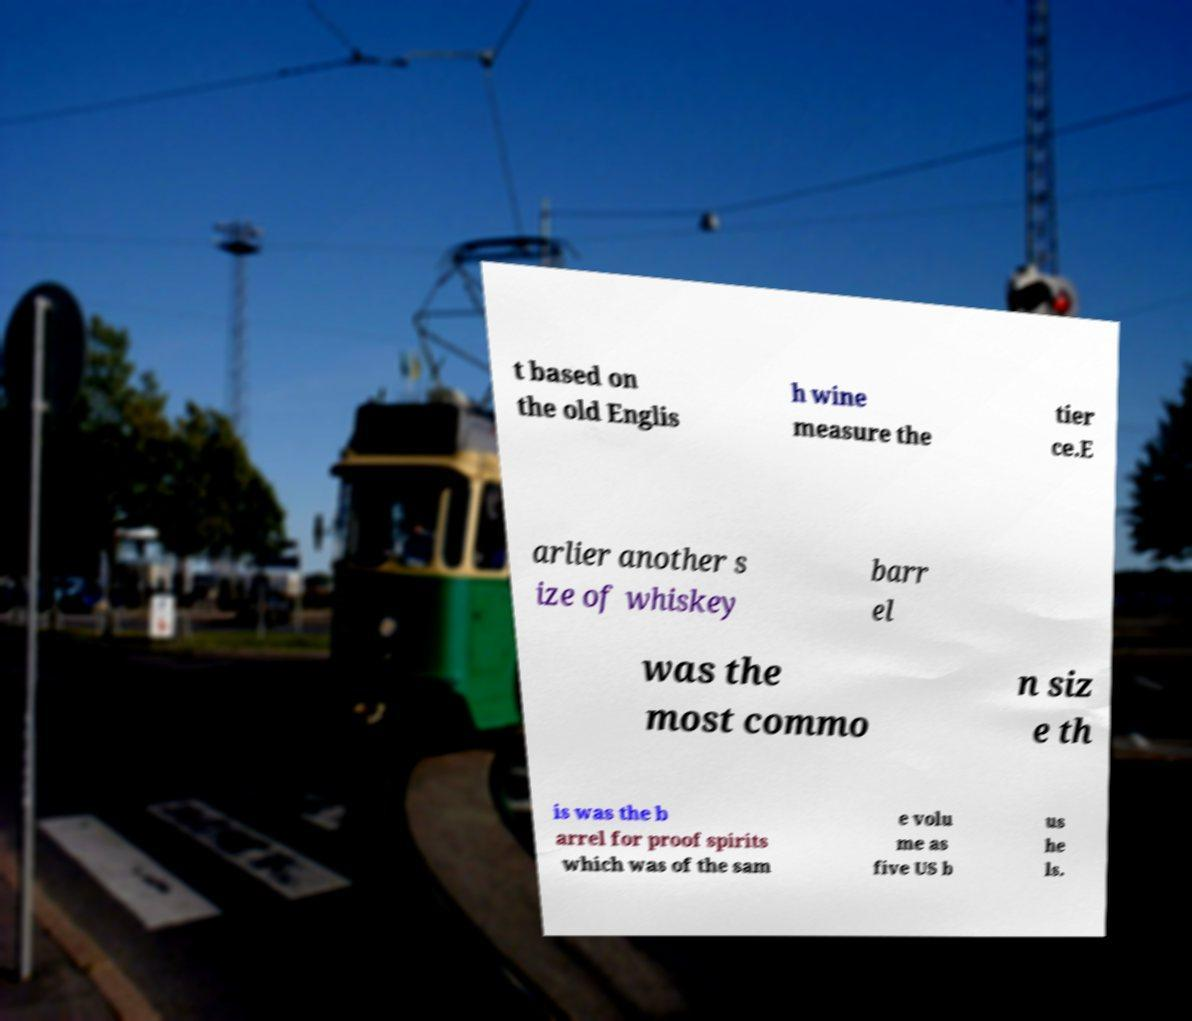Can you read and provide the text displayed in the image?This photo seems to have some interesting text. Can you extract and type it out for me? t based on the old Englis h wine measure the tier ce.E arlier another s ize of whiskey barr el was the most commo n siz e th is was the b arrel for proof spirits which was of the sam e volu me as five US b us he ls. 